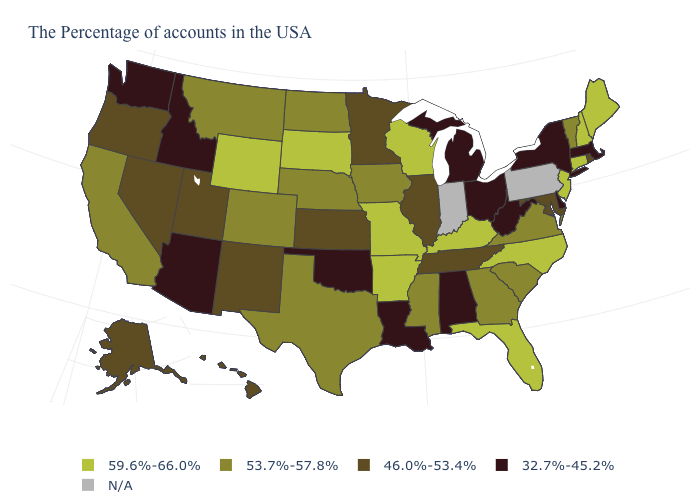What is the value of Washington?
Quick response, please. 32.7%-45.2%. What is the value of Pennsylvania?
Answer briefly. N/A. Does the first symbol in the legend represent the smallest category?
Quick response, please. No. Name the states that have a value in the range 53.7%-57.8%?
Concise answer only. Vermont, Virginia, South Carolina, Georgia, Mississippi, Iowa, Nebraska, Texas, North Dakota, Colorado, Montana, California. Name the states that have a value in the range N/A?
Quick response, please. Pennsylvania, Indiana. Name the states that have a value in the range 46.0%-53.4%?
Give a very brief answer. Rhode Island, Maryland, Tennessee, Illinois, Minnesota, Kansas, New Mexico, Utah, Nevada, Oregon, Alaska, Hawaii. Does Texas have the highest value in the USA?
Answer briefly. No. Does Louisiana have the highest value in the USA?
Give a very brief answer. No. What is the value of Indiana?
Give a very brief answer. N/A. What is the value of Maryland?
Keep it brief. 46.0%-53.4%. Which states hav the highest value in the South?
Keep it brief. North Carolina, Florida, Kentucky, Arkansas. Name the states that have a value in the range N/A?
Keep it brief. Pennsylvania, Indiana. Does Mississippi have the highest value in the USA?
Concise answer only. No. Name the states that have a value in the range N/A?
Write a very short answer. Pennsylvania, Indiana. 